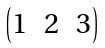Convert formula to latex. <formula><loc_0><loc_0><loc_500><loc_500>\begin{pmatrix} 1 & 2 & 3 \end{pmatrix}</formula> 